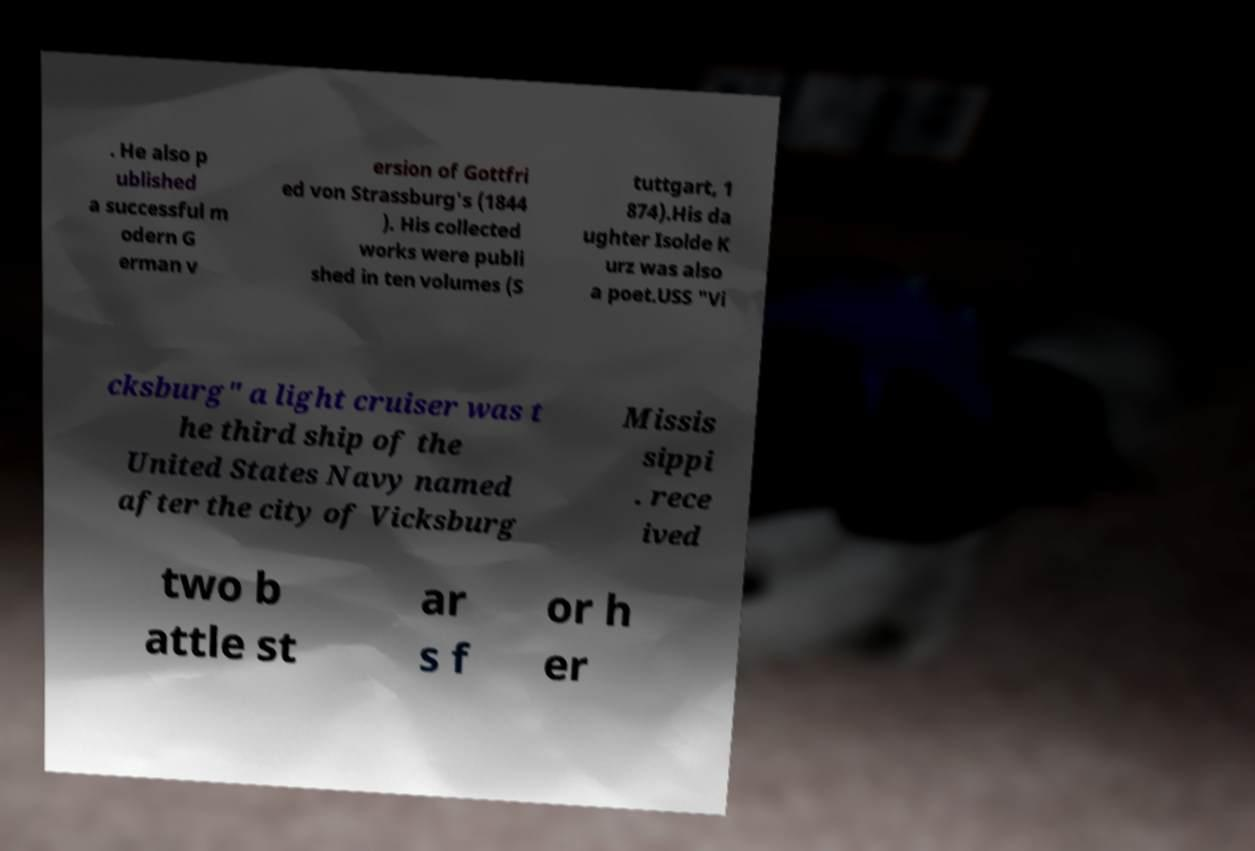Please read and relay the text visible in this image. What does it say? . He also p ublished a successful m odern G erman v ersion of Gottfri ed von Strassburg's (1844 ). His collected works were publi shed in ten volumes (S tuttgart, 1 874).His da ughter Isolde K urz was also a poet.USS "Vi cksburg" a light cruiser was t he third ship of the United States Navy named after the city of Vicksburg Missis sippi . rece ived two b attle st ar s f or h er 